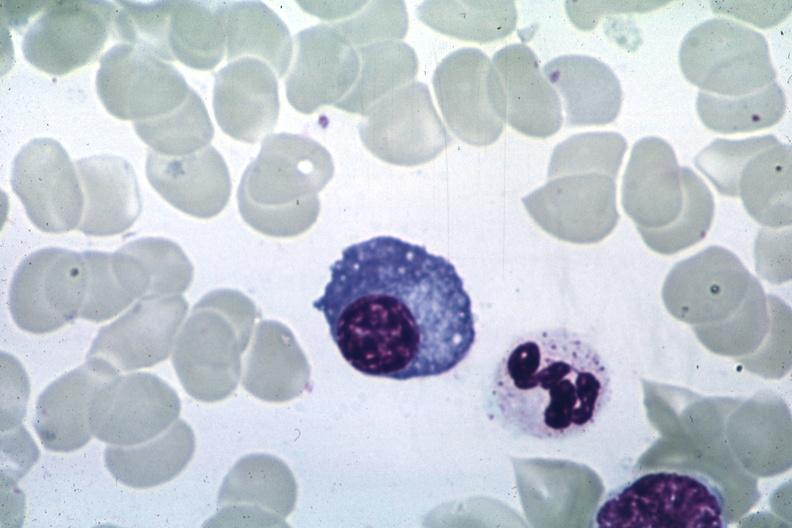s fat necrosis present?
Answer the question using a single word or phrase. No 